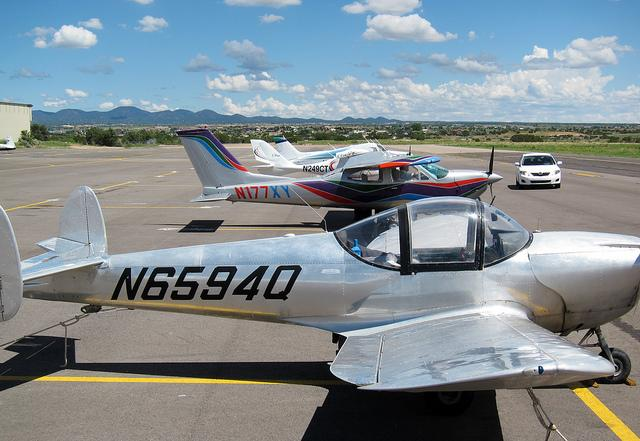What are cables hooked to these planes for? keep down 